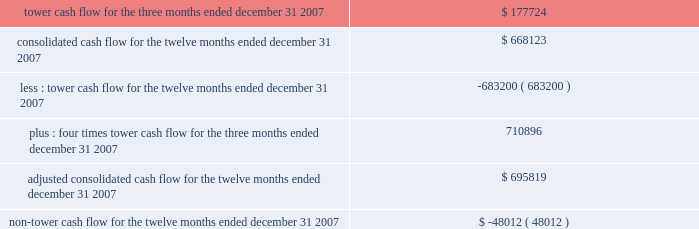The table presents tower cash flow , adjusted consolidated cash flow and non-tower cash flow for the company and its restricted subsidiaries , as defined in the indentures for the applicable notes ( in thousands ) : .

What portion of consolidated cashflow for the twelve months ended december 31 , 2007 is related to tower cash flow twelve months? 
Computations: (683200 / 668123)
Answer: 1.02257. 